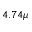Convert formula to latex. <formula><loc_0><loc_0><loc_500><loc_500>4 . 7 4 \mu</formula> 